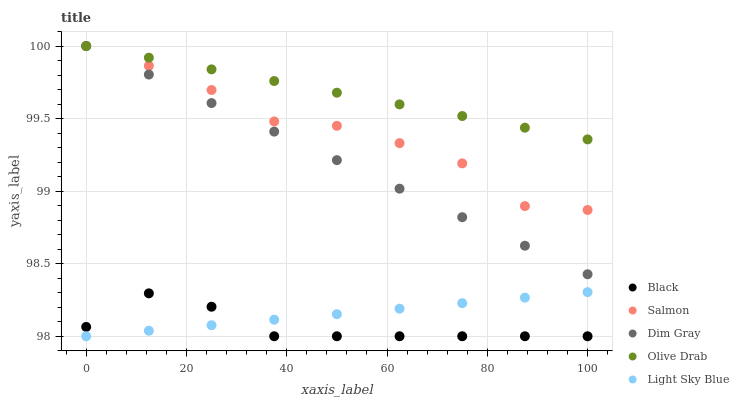Does Black have the minimum area under the curve?
Answer yes or no. Yes. Does Olive Drab have the maximum area under the curve?
Answer yes or no. Yes. Does Dim Gray have the minimum area under the curve?
Answer yes or no. No. Does Dim Gray have the maximum area under the curve?
Answer yes or no. No. Is Dim Gray the smoothest?
Answer yes or no. Yes. Is Salmon the roughest?
Answer yes or no. Yes. Is Black the smoothest?
Answer yes or no. No. Is Black the roughest?
Answer yes or no. No. Does Black have the lowest value?
Answer yes or no. Yes. Does Dim Gray have the lowest value?
Answer yes or no. No. Does Olive Drab have the highest value?
Answer yes or no. Yes. Does Black have the highest value?
Answer yes or no. No. Is Light Sky Blue less than Olive Drab?
Answer yes or no. Yes. Is Olive Drab greater than Light Sky Blue?
Answer yes or no. Yes. Does Black intersect Light Sky Blue?
Answer yes or no. Yes. Is Black less than Light Sky Blue?
Answer yes or no. No. Is Black greater than Light Sky Blue?
Answer yes or no. No. Does Light Sky Blue intersect Olive Drab?
Answer yes or no. No. 